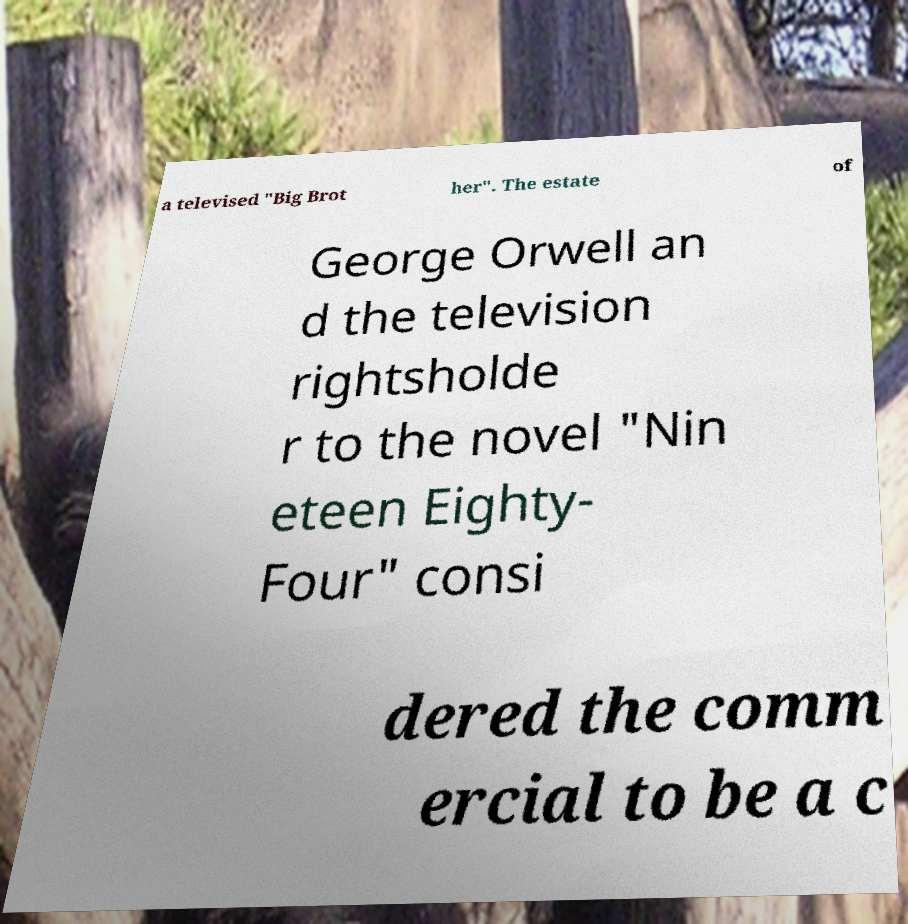Please identify and transcribe the text found in this image. a televised "Big Brot her". The estate of George Orwell an d the television rightsholde r to the novel "Nin eteen Eighty- Four" consi dered the comm ercial to be a c 